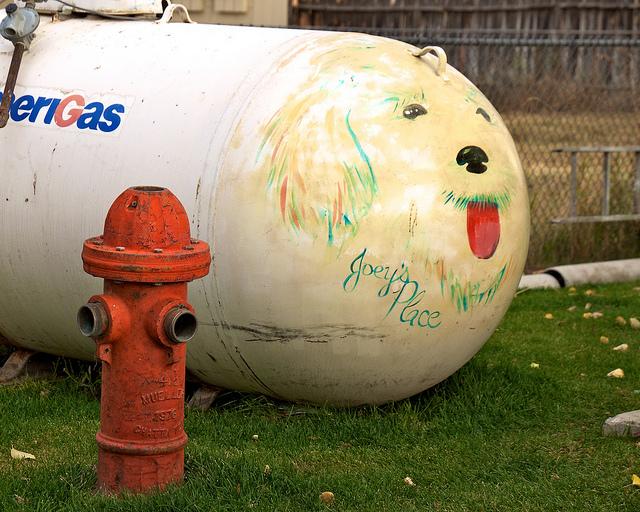Is the animal smiling?
Concise answer only. Yes. What kind of face is painted on the tank?
Write a very short answer. Dog. What is written below the face?
Short answer required. Joey's place. 